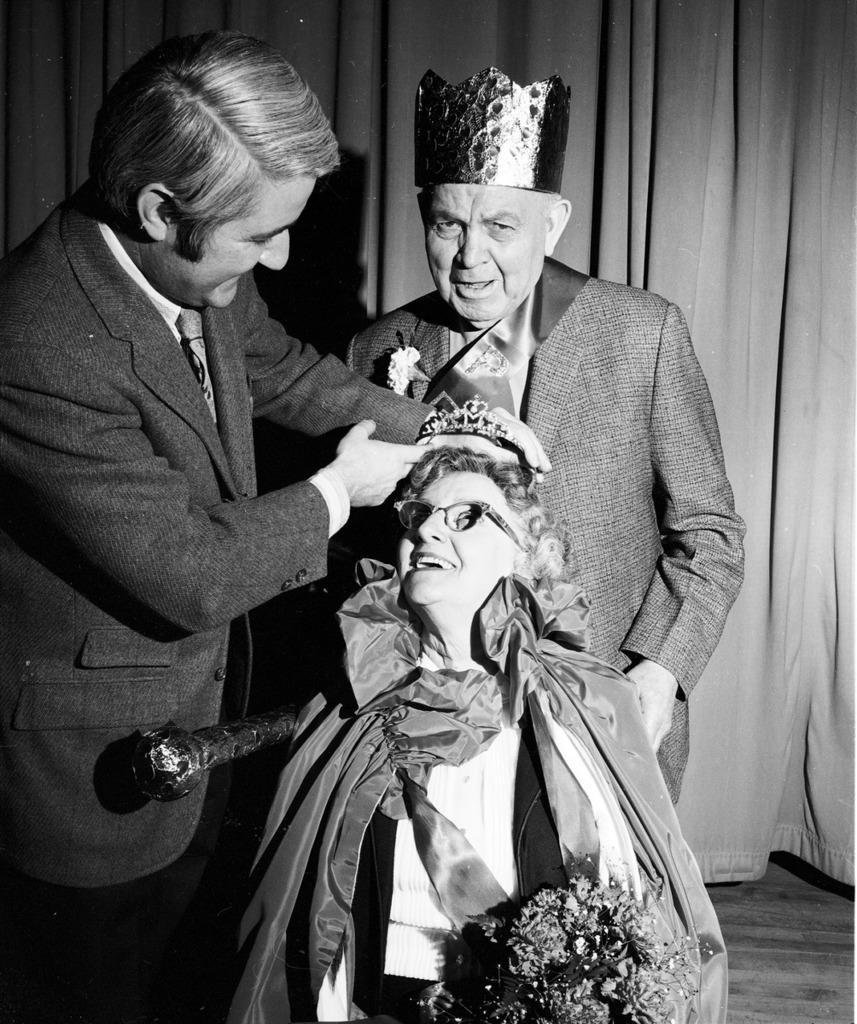Could you give a brief overview of what you see in this image? In this given picture, I can see a women sitting and holding a flower bookey and wearing specs and they're other two people, Who are standing towards left there is a men, Who is holding her crown and behind this three people, There is a curtain. 